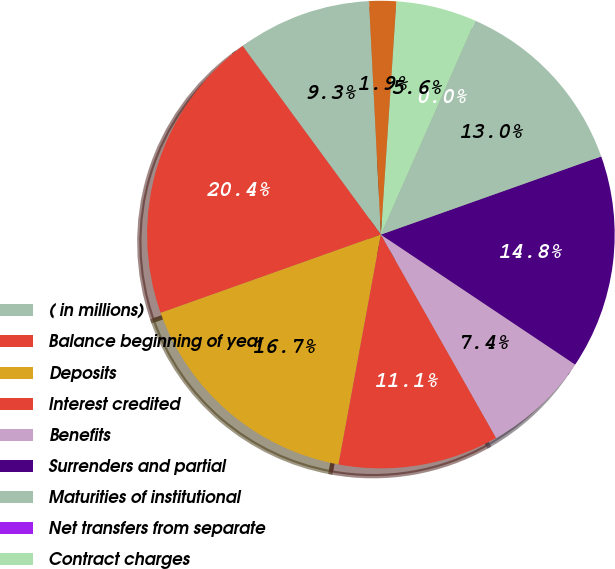Convert chart to OTSL. <chart><loc_0><loc_0><loc_500><loc_500><pie_chart><fcel>( in millions)<fcel>Balance beginning of year<fcel>Deposits<fcel>Interest credited<fcel>Benefits<fcel>Surrenders and partial<fcel>Maturities of institutional<fcel>Net transfers from separate<fcel>Contract charges<fcel>Fair value hedge adjustments<nl><fcel>9.26%<fcel>20.37%<fcel>16.66%<fcel>11.11%<fcel>7.41%<fcel>14.81%<fcel>12.96%<fcel>0.0%<fcel>5.56%<fcel>1.86%<nl></chart> 